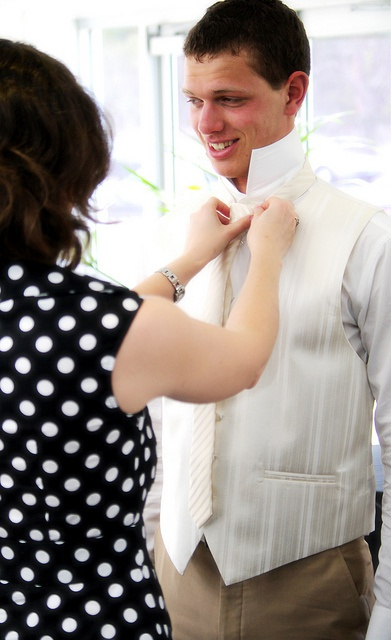Describe the objects in this image and their specific colors. I can see people in white, lightgray, darkgray, black, and brown tones, people in white, black, tan, and lightgray tones, and tie in white, tan, and darkgray tones in this image. 